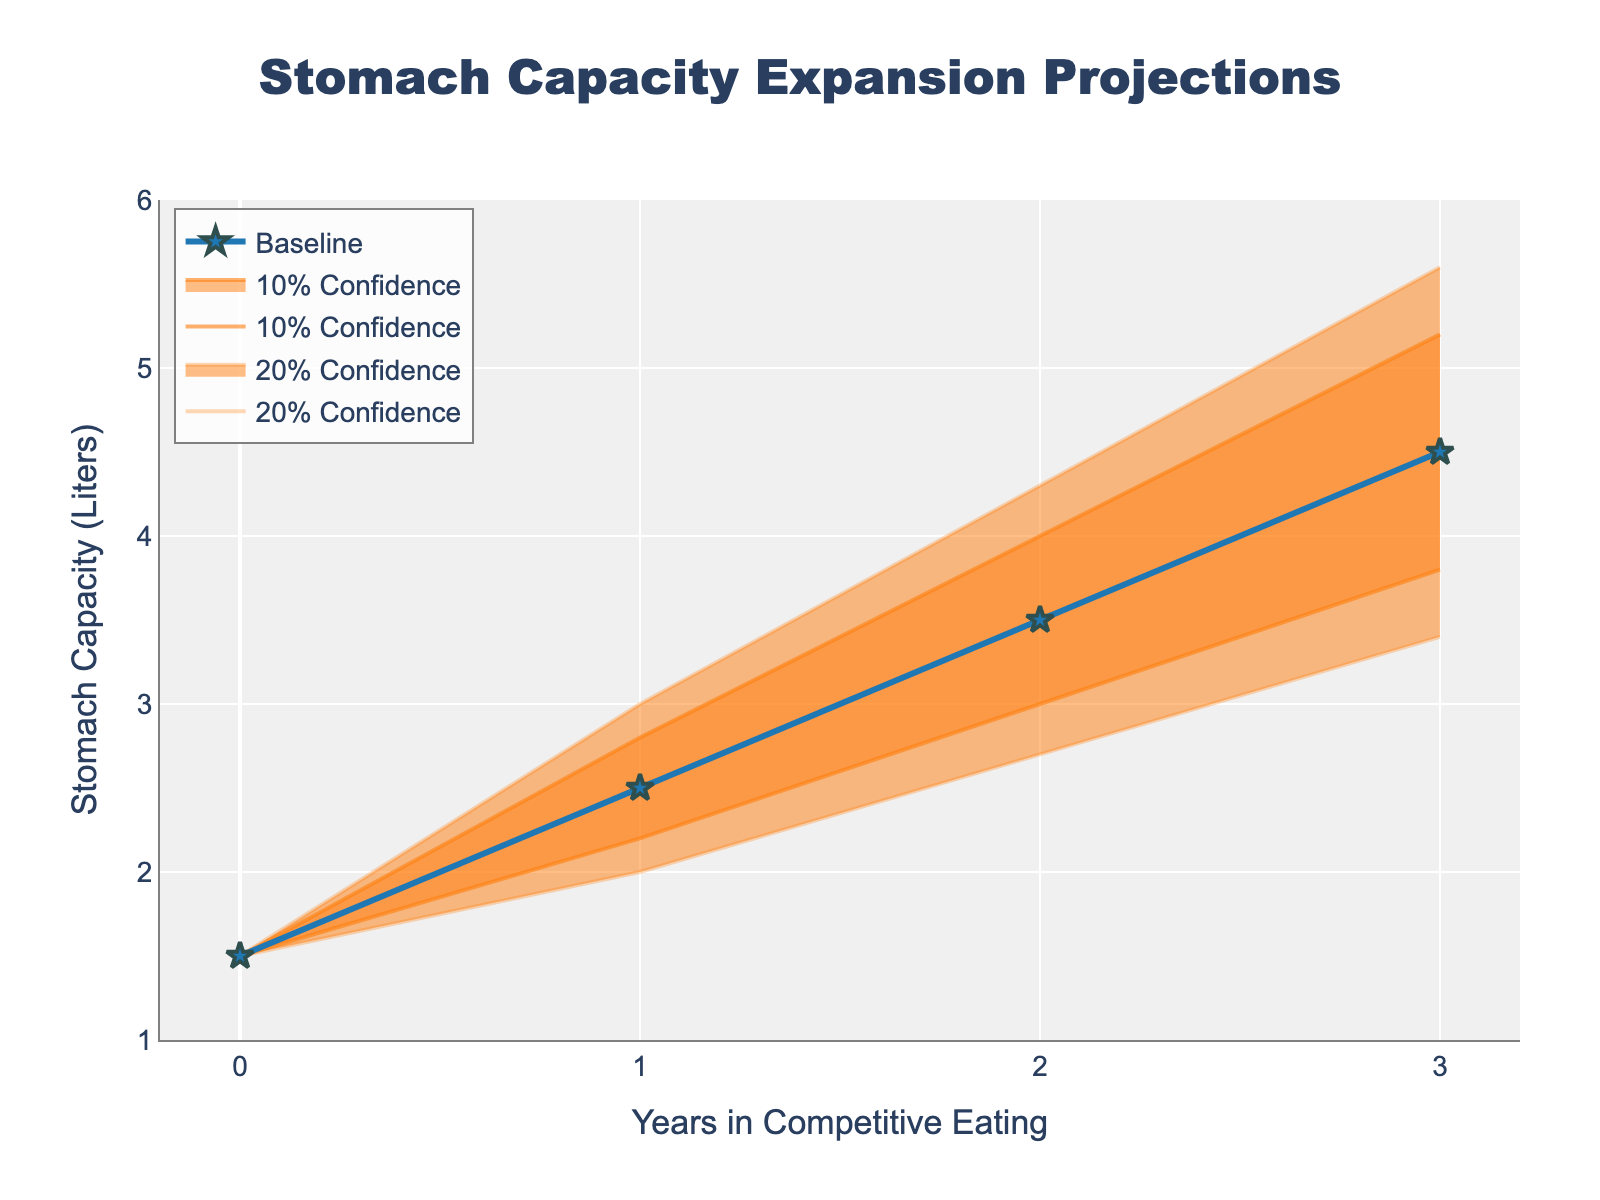What's the title of the figure? The title of the figure is usually found at the top center. In this figure, it reads "Stomach Capacity Expansion Projections" in bold letters.
Answer: Stomach Capacity Expansion Projections How many years of data are plotted in the figure? The x-axis label shows numbers representing years, running from 0 to 3 inclusive, indicating data over 4 years.
Answer: 4 years What is the baseline stomach capacity at the start (Year 0)? By checking the baseline line at the start (Year 0), we see that it intersects the y-axis at 1.5 liters.
Answer: 1.5 liters Which confidence level displays a broader prediction range in Year 3, the 10% or the 20%? By comparing the bands delineated by the confidence levels, we see that the 20% confidence level has a broader range from the lower to the upper bound.
Answer: 20% What is the minimum projected stomach capacity in Year 2 within the 20% confidence level? Checking the lower bound of the 20% confidence interval for Year 2, it indicates a value of 2.7 liters.
Answer: 2.7 liters What is the difference between the lowest and highest projected capacities in Year 1 within the 10% confidence level? Referring to the vertical span of the 10% confidence interval in Year 1, the difference is calculated as 2.8 - 2.2 = 0.6 liters.
Answer: 0.6 liters How does the projected stomach capacity at Year 3 compare with Year 1 for the baseline? Inspecting the baseline line, it shows an increase from 2.5 liters in Year 1 to 4.5 liters in Year 3, indicating significant growth over time.
Answer: Increase What is the median value of the upper bound of the 10% confidence interval from Year 0 to Year 3? Arrange the upper bound values for the 10% confidence interval {1.5, 2.8, 4.0, 5.2} in order and find the average of the two middle values, (2.8 + 4.0)/2 = 3.4 liters.
Answer: 3.4 liters Between which years is the steepest upward slope observed for the baseline stomach capacity? The steepest upward slope will occur where there's the most considerable increase in y-values between two consecutive years. From Year 0 to Year 1, it rises by 1 liter, and from Year 1 to Year 2 by another 1 liter. The next year-to-year changes show consistent growths. Hence, Year 2 to Year 3 shows the largest increase of 1 liter, concluding no unique steepest slope but consistent increases.
Answer: Year 2 to Year 3 